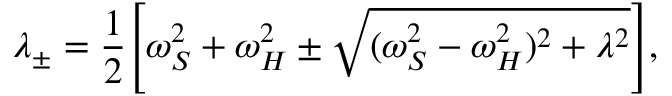Convert formula to latex. <formula><loc_0><loc_0><loc_500><loc_500>\lambda _ { \pm } = \frac { 1 } { 2 } \left [ \omega _ { S } ^ { 2 } + \omega _ { H } ^ { 2 } \pm \sqrt { ( \omega _ { S } ^ { 2 } - \omega _ { H } ^ { 2 } ) ^ { 2 } + \lambda ^ { 2 } } \right ] ,</formula> 